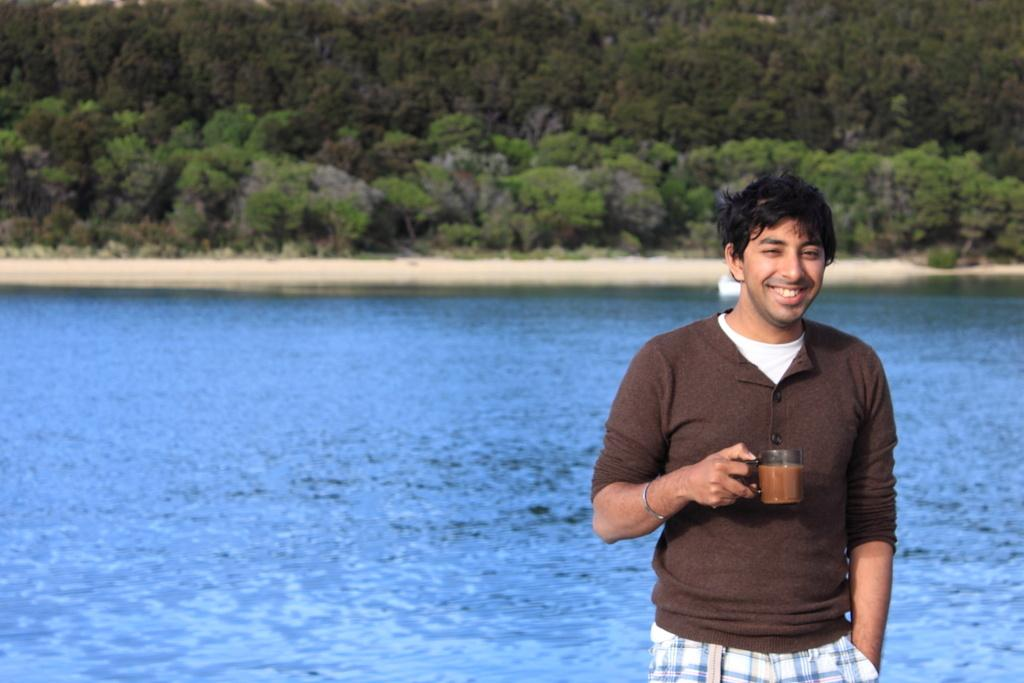Who is present in the image? There is a man in the image. What is the man holding in the image? The man is holding a cup. What is inside the cup? The cup contains a drink. What can be seen in the background of the image? There is water and trees visible in the background of the image. What type of punishment is being administered to the trees in the background of the image? There is no punishment being administered to the trees in the image; they are simply visible in the background. 